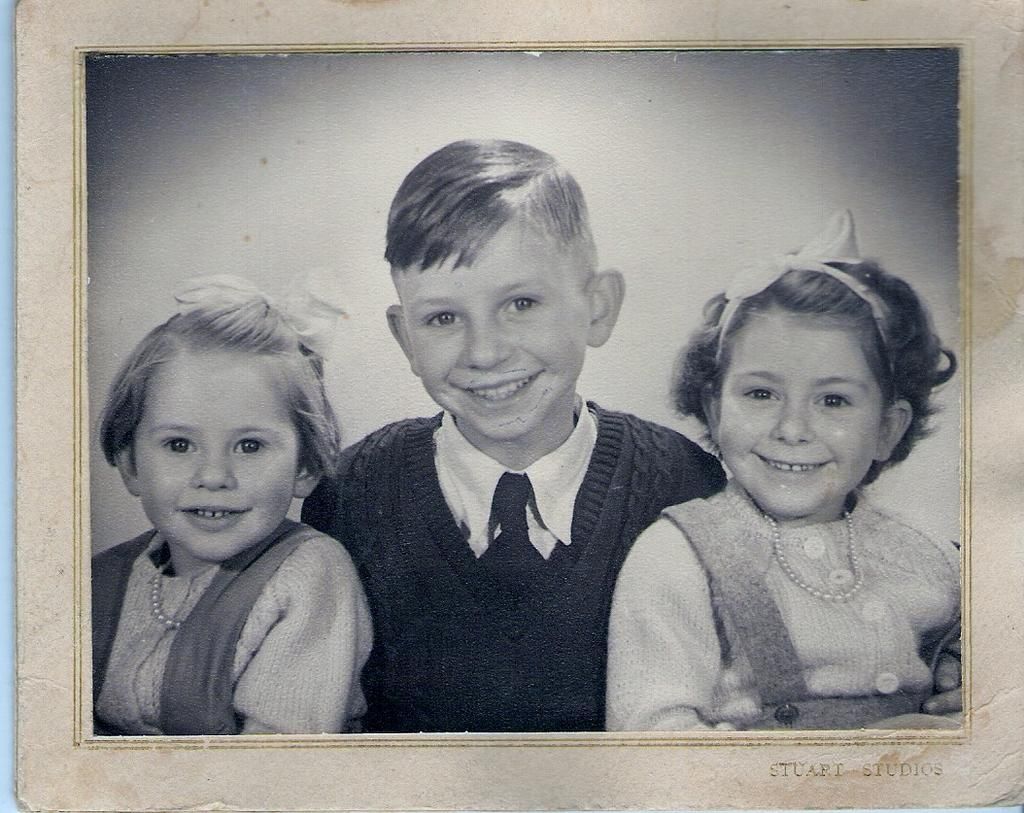What is the main subject of the image? There is a photograph in the image. What can be seen in the photograph? The photograph contains smiling girls and a boy. Is there any text present in the image? Yes, there is text in the bottom right corner of the image. What type of thread is being used by the boy in the photograph? There is no thread visible in the photograph, and the boy is not performing any activity that would involve thread. 